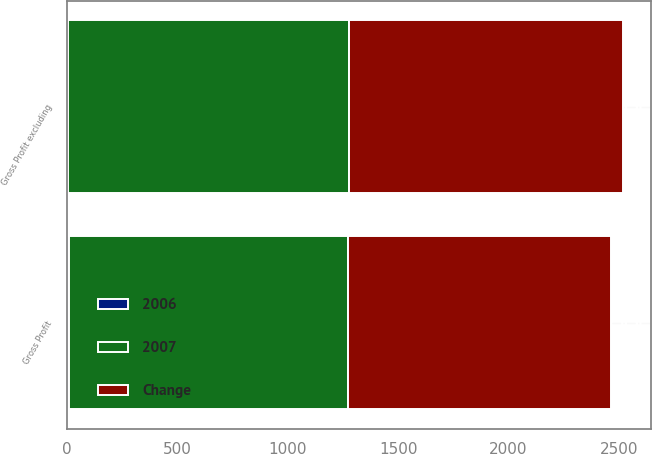<chart> <loc_0><loc_0><loc_500><loc_500><stacked_bar_chart><ecel><fcel>Gross Profit<fcel>Gross Profit excluding<nl><fcel>Change<fcel>1192<fcel>1241<nl><fcel>2007<fcel>1265<fcel>1275<nl><fcel>2006<fcel>6<fcel>3<nl></chart> 